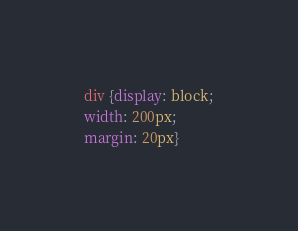Convert code to text. <code><loc_0><loc_0><loc_500><loc_500><_CSS_>div {display: block;
width: 200px;
margin: 20px}
</code> 